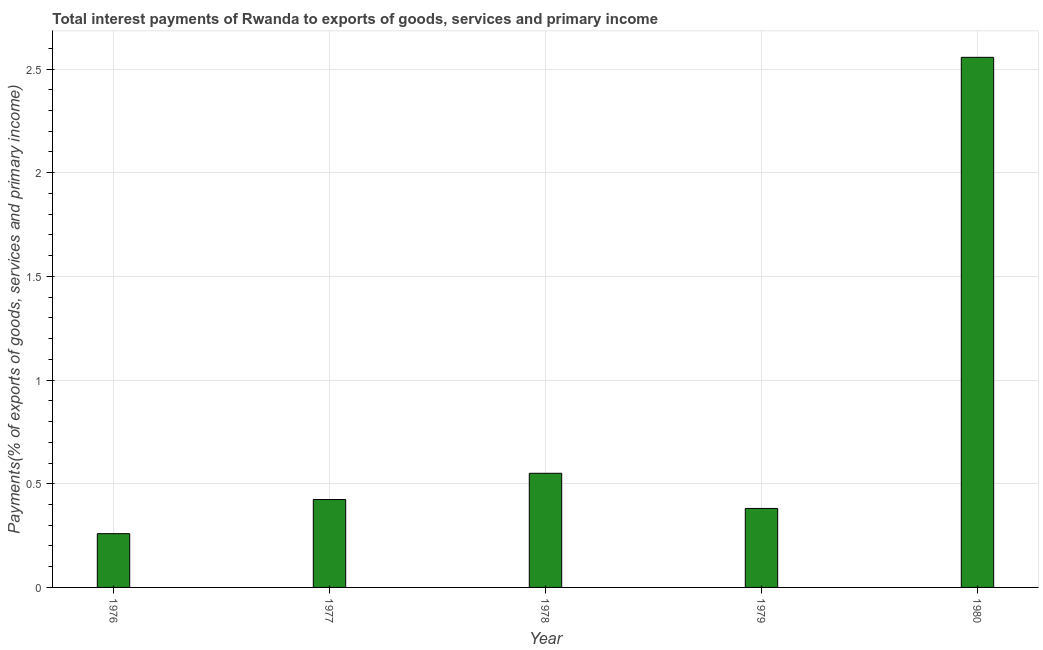Does the graph contain grids?
Your response must be concise. Yes. What is the title of the graph?
Give a very brief answer. Total interest payments of Rwanda to exports of goods, services and primary income. What is the label or title of the X-axis?
Your response must be concise. Year. What is the label or title of the Y-axis?
Your answer should be very brief. Payments(% of exports of goods, services and primary income). What is the total interest payments on external debt in 1977?
Give a very brief answer. 0.42. Across all years, what is the maximum total interest payments on external debt?
Ensure brevity in your answer.  2.56. Across all years, what is the minimum total interest payments on external debt?
Your answer should be compact. 0.26. In which year was the total interest payments on external debt maximum?
Your answer should be very brief. 1980. In which year was the total interest payments on external debt minimum?
Your answer should be compact. 1976. What is the sum of the total interest payments on external debt?
Ensure brevity in your answer.  4.17. What is the difference between the total interest payments on external debt in 1976 and 1978?
Your answer should be very brief. -0.29. What is the average total interest payments on external debt per year?
Provide a short and direct response. 0.83. What is the median total interest payments on external debt?
Provide a succinct answer. 0.42. Do a majority of the years between 1977 and 1980 (inclusive) have total interest payments on external debt greater than 1 %?
Your answer should be compact. No. What is the ratio of the total interest payments on external debt in 1976 to that in 1979?
Your answer should be compact. 0.68. Is the total interest payments on external debt in 1977 less than that in 1980?
Your answer should be compact. Yes. What is the difference between the highest and the second highest total interest payments on external debt?
Your response must be concise. 2.01. What is the difference between the highest and the lowest total interest payments on external debt?
Offer a terse response. 2.3. How many bars are there?
Provide a short and direct response. 5. Are all the bars in the graph horizontal?
Your answer should be very brief. No. How many years are there in the graph?
Ensure brevity in your answer.  5. What is the difference between two consecutive major ticks on the Y-axis?
Your answer should be compact. 0.5. Are the values on the major ticks of Y-axis written in scientific E-notation?
Provide a succinct answer. No. What is the Payments(% of exports of goods, services and primary income) of 1976?
Provide a short and direct response. 0.26. What is the Payments(% of exports of goods, services and primary income) in 1977?
Ensure brevity in your answer.  0.42. What is the Payments(% of exports of goods, services and primary income) in 1978?
Provide a succinct answer. 0.55. What is the Payments(% of exports of goods, services and primary income) of 1979?
Offer a very short reply. 0.38. What is the Payments(% of exports of goods, services and primary income) of 1980?
Offer a very short reply. 2.56. What is the difference between the Payments(% of exports of goods, services and primary income) in 1976 and 1977?
Your response must be concise. -0.16. What is the difference between the Payments(% of exports of goods, services and primary income) in 1976 and 1978?
Your response must be concise. -0.29. What is the difference between the Payments(% of exports of goods, services and primary income) in 1976 and 1979?
Your answer should be compact. -0.12. What is the difference between the Payments(% of exports of goods, services and primary income) in 1976 and 1980?
Offer a terse response. -2.3. What is the difference between the Payments(% of exports of goods, services and primary income) in 1977 and 1978?
Make the answer very short. -0.13. What is the difference between the Payments(% of exports of goods, services and primary income) in 1977 and 1979?
Ensure brevity in your answer.  0.04. What is the difference between the Payments(% of exports of goods, services and primary income) in 1977 and 1980?
Keep it short and to the point. -2.13. What is the difference between the Payments(% of exports of goods, services and primary income) in 1978 and 1979?
Keep it short and to the point. 0.17. What is the difference between the Payments(% of exports of goods, services and primary income) in 1978 and 1980?
Provide a succinct answer. -2.01. What is the difference between the Payments(% of exports of goods, services and primary income) in 1979 and 1980?
Give a very brief answer. -2.18. What is the ratio of the Payments(% of exports of goods, services and primary income) in 1976 to that in 1977?
Provide a succinct answer. 0.61. What is the ratio of the Payments(% of exports of goods, services and primary income) in 1976 to that in 1978?
Your answer should be compact. 0.47. What is the ratio of the Payments(% of exports of goods, services and primary income) in 1976 to that in 1979?
Provide a succinct answer. 0.68. What is the ratio of the Payments(% of exports of goods, services and primary income) in 1976 to that in 1980?
Keep it short and to the point. 0.1. What is the ratio of the Payments(% of exports of goods, services and primary income) in 1977 to that in 1978?
Give a very brief answer. 0.77. What is the ratio of the Payments(% of exports of goods, services and primary income) in 1977 to that in 1979?
Your answer should be very brief. 1.11. What is the ratio of the Payments(% of exports of goods, services and primary income) in 1977 to that in 1980?
Offer a very short reply. 0.17. What is the ratio of the Payments(% of exports of goods, services and primary income) in 1978 to that in 1979?
Keep it short and to the point. 1.45. What is the ratio of the Payments(% of exports of goods, services and primary income) in 1978 to that in 1980?
Ensure brevity in your answer.  0.21. What is the ratio of the Payments(% of exports of goods, services and primary income) in 1979 to that in 1980?
Provide a succinct answer. 0.15. 